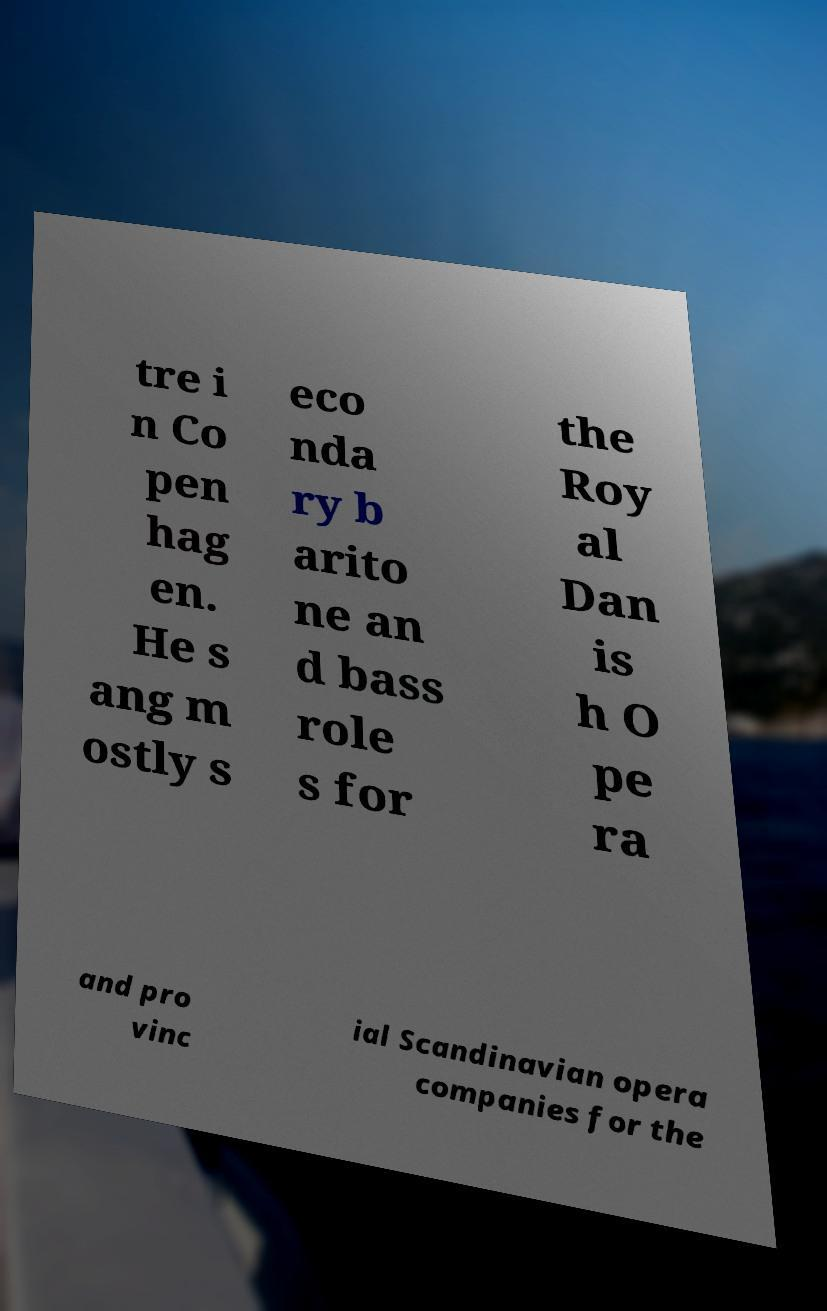There's text embedded in this image that I need extracted. Can you transcribe it verbatim? tre i n Co pen hag en. He s ang m ostly s eco nda ry b arito ne an d bass role s for the Roy al Dan is h O pe ra and pro vinc ial Scandinavian opera companies for the 